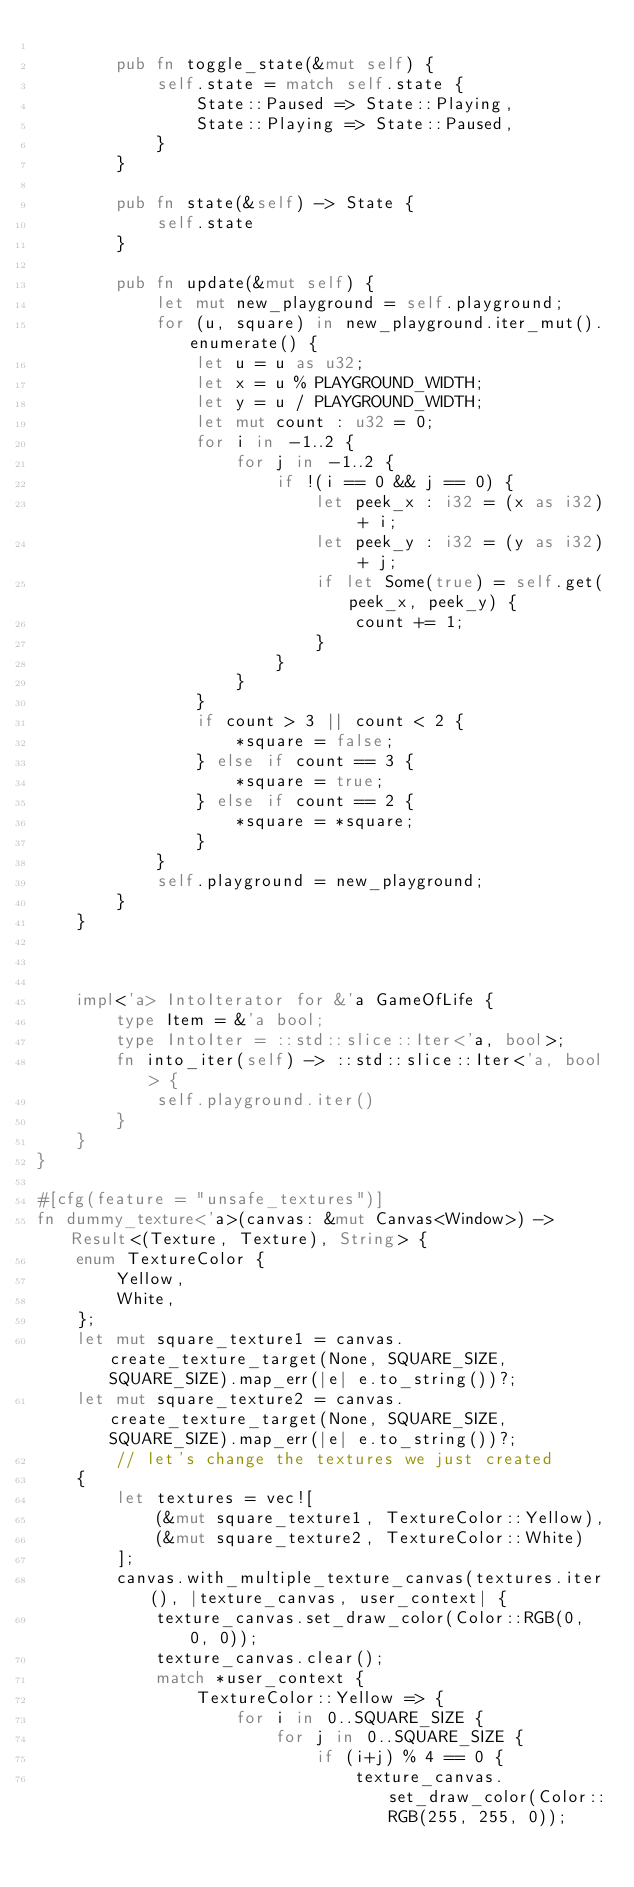<code> <loc_0><loc_0><loc_500><loc_500><_Rust_>
        pub fn toggle_state(&mut self) {
            self.state = match self.state {
                State::Paused => State::Playing,
                State::Playing => State::Paused,
            }
        }

        pub fn state(&self) -> State {
            self.state
        }

        pub fn update(&mut self) {
            let mut new_playground = self.playground;
            for (u, square) in new_playground.iter_mut().enumerate() {
                let u = u as u32;
                let x = u % PLAYGROUND_WIDTH;
                let y = u / PLAYGROUND_WIDTH;
                let mut count : u32 = 0;
                for i in -1..2 {
                    for j in -1..2 {
                        if !(i == 0 && j == 0) {
                            let peek_x : i32 = (x as i32) + i;
                            let peek_y : i32 = (y as i32) + j;
                            if let Some(true) = self.get(peek_x, peek_y) {
                                count += 1;
                            }
                        }
                    }
                }
                if count > 3 || count < 2 {
                    *square = false;
                } else if count == 3 {
                    *square = true;
                } else if count == 2 {
                    *square = *square;
                }
            }
            self.playground = new_playground;
        }
    }



    impl<'a> IntoIterator for &'a GameOfLife {
        type Item = &'a bool;
        type IntoIter = ::std::slice::Iter<'a, bool>;
        fn into_iter(self) -> ::std::slice::Iter<'a, bool> {
            self.playground.iter()
        }
    }
}

#[cfg(feature = "unsafe_textures")]
fn dummy_texture<'a>(canvas: &mut Canvas<Window>) -> Result<(Texture, Texture), String> {
    enum TextureColor {
        Yellow,
        White,
    };
    let mut square_texture1 = canvas.create_texture_target(None, SQUARE_SIZE, SQUARE_SIZE).map_err(|e| e.to_string())?;
    let mut square_texture2 = canvas.create_texture_target(None, SQUARE_SIZE, SQUARE_SIZE).map_err(|e| e.to_string())?;
        // let's change the textures we just created
    {
        let textures = vec![
            (&mut square_texture1, TextureColor::Yellow),
            (&mut square_texture2, TextureColor::White)
        ];
        canvas.with_multiple_texture_canvas(textures.iter(), |texture_canvas, user_context| {
            texture_canvas.set_draw_color(Color::RGB(0, 0, 0));
            texture_canvas.clear();
            match *user_context {
                TextureColor::Yellow => {
                    for i in 0..SQUARE_SIZE {
                        for j in 0..SQUARE_SIZE {
                            if (i+j) % 4 == 0 {
                                texture_canvas.set_draw_color(Color::RGB(255, 255, 0));</code> 